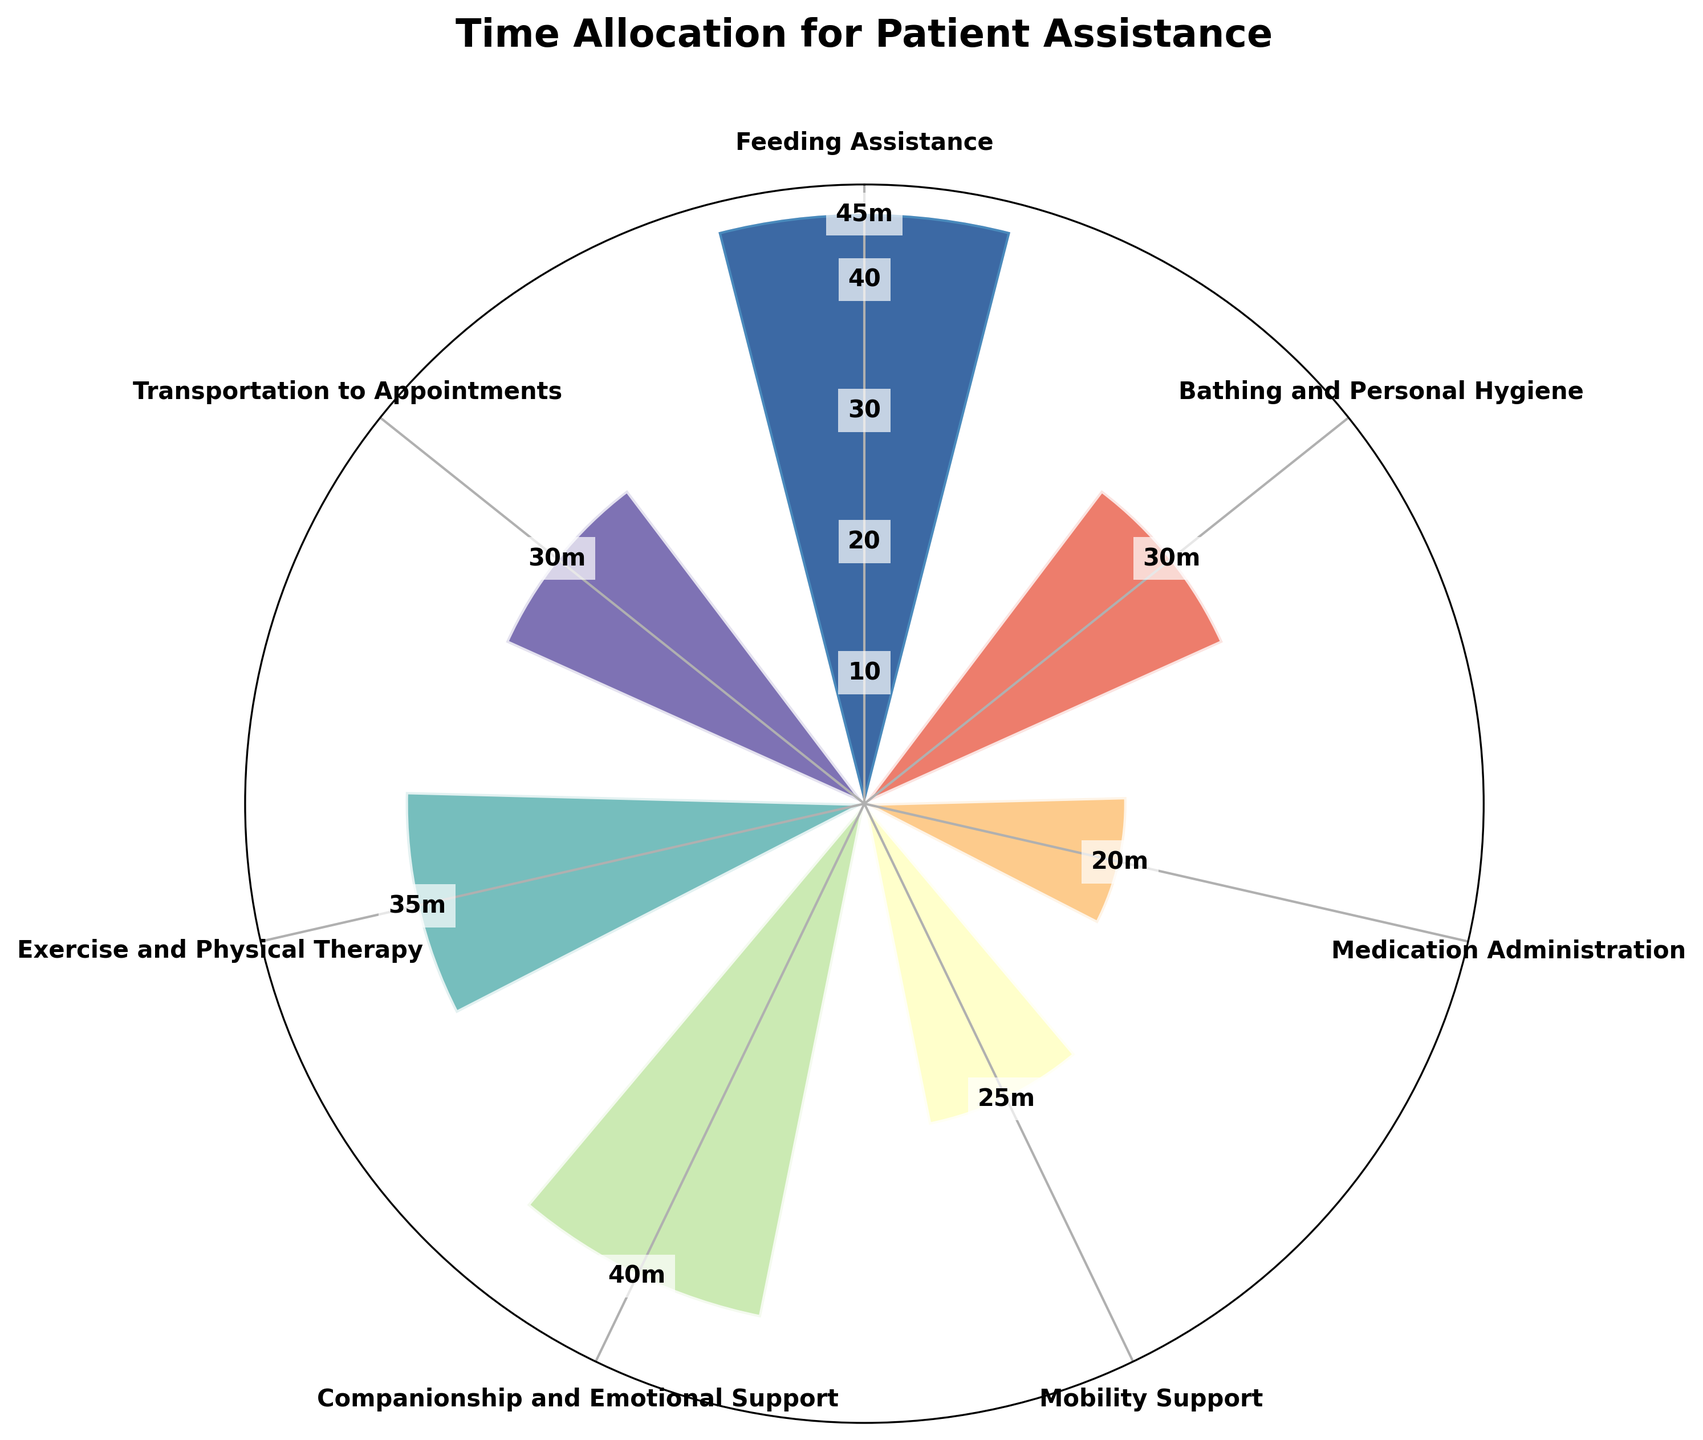What's the title of the chart? The title is typically displayed at the top of the chart. In this case, the title is clearly mentioned.
Answer: Time Allocation for Patient Assistance Which category has the highest time allocation? Locate the bar that extends furthest from the center of the polar area chart. This indicates the highest time allocation.
Answer: Feeding Assistance How much time is allocated to Exercise and Physical Therapy daily? Find the bar labeled as "Exercise and Physical Therapy" and note its length, which represents the time allocation.
Answer: 35 minutes How much more time is spent on Feeding Assistance than on Medication Administration? Compare the lengths of the bars for "Feeding Assistance" and "Medication Administration" and subtract the smaller value from the larger one.
Answer: 25 minutes Which two categories have equal time allocations? Look for bars of equal length and confirm the labels.
Answer: Bathing and Personal Hygiene and Transportation to Appointments What is the total time allocated to Mobility Support and Companionship and Emotional Support? Add the time allocations of "Mobility Support" and "Companionship and Emotional Support".
Answer: 65 minutes Which category has the second lowest time allocation and how much is it? Identify the second smallest bar by comparing their lengths and quantities.
Answer: Mobility Support, 25 minutes What is the average time allocation across all categories? Sum up all the time allocations and divide by the number of categories. (45 + 30 + 20 + 25 + 40 + 35 + 30) / 7 = 225 / 7
Answer: 32.14 minutes Is there any category that has a time allocation less than 20 minutes? Examine all bar lengths and identify if any are below the 20-minute mark.
Answer: No Which takes more time, Exercise and Physical Therapy or Transportation to Appointments? Compare the lengths of the bars for "Exercise and Physical Therapy" and "Transportation to Appointments".
Answer: Exercise and Physical Therapy 